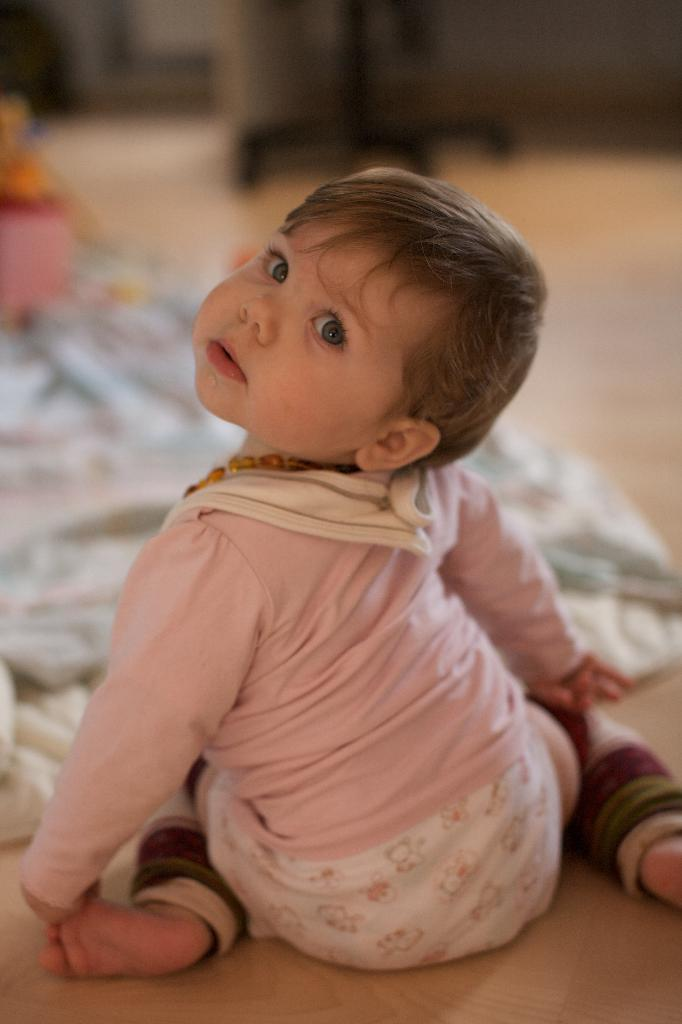What is the boy doing in the image? The boy is sitting on the floor in the image. What is in front of the boy? There is a blanket in front of the boy. Can you describe any other objects present in the image? Unfortunately, the provided facts do not mention any other objects present in the image. What type of music is the boy listening to in the image? There is no information about music in the image, as it only mentions the boy sitting on the floor and the presence of a blanket. 